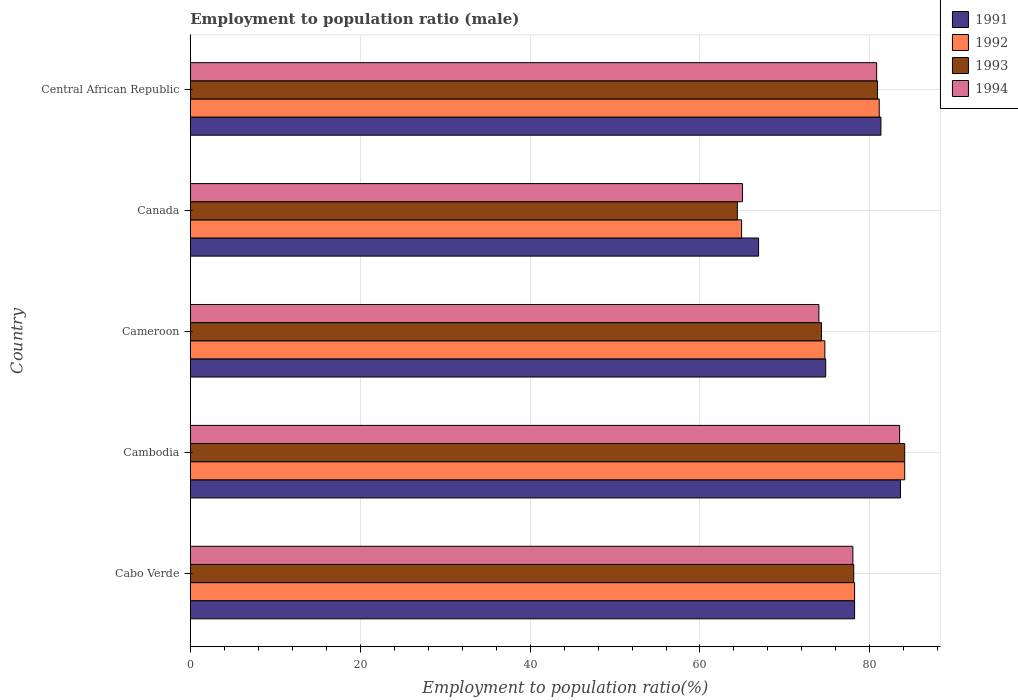How many groups of bars are there?
Offer a terse response. 5. Are the number of bars per tick equal to the number of legend labels?
Your answer should be compact. Yes. Are the number of bars on each tick of the Y-axis equal?
Your answer should be compact. Yes. How many bars are there on the 2nd tick from the top?
Ensure brevity in your answer.  4. What is the label of the 4th group of bars from the top?
Offer a very short reply. Cambodia. In how many cases, is the number of bars for a given country not equal to the number of legend labels?
Your response must be concise. 0. What is the employment to population ratio in 1994 in Cambodia?
Your answer should be very brief. 83.5. Across all countries, what is the maximum employment to population ratio in 1991?
Make the answer very short. 83.6. In which country was the employment to population ratio in 1991 maximum?
Provide a short and direct response. Cambodia. In which country was the employment to population ratio in 1991 minimum?
Offer a terse response. Canada. What is the total employment to population ratio in 1991 in the graph?
Ensure brevity in your answer.  384.8. What is the difference between the employment to population ratio in 1992 in Cameroon and that in Canada?
Your response must be concise. 9.8. What is the difference between the employment to population ratio in 1991 in Central African Republic and the employment to population ratio in 1993 in Canada?
Your answer should be compact. 16.9. What is the average employment to population ratio in 1992 per country?
Provide a succinct answer. 76.6. What is the difference between the employment to population ratio in 1993 and employment to population ratio in 1994 in Central African Republic?
Offer a very short reply. 0.1. In how many countries, is the employment to population ratio in 1991 greater than 64 %?
Offer a terse response. 5. What is the ratio of the employment to population ratio in 1992 in Cabo Verde to that in Canada?
Offer a terse response. 1.2. Is the employment to population ratio in 1991 in Cabo Verde less than that in Cameroon?
Provide a short and direct response. No. What is the difference between the highest and the second highest employment to population ratio in 1994?
Provide a succinct answer. 2.7. Is it the case that in every country, the sum of the employment to population ratio in 1991 and employment to population ratio in 1993 is greater than the sum of employment to population ratio in 1994 and employment to population ratio in 1992?
Provide a succinct answer. No. What does the 3rd bar from the top in Central African Republic represents?
Make the answer very short. 1992. What does the 2nd bar from the bottom in Central African Republic represents?
Your answer should be very brief. 1992. Are all the bars in the graph horizontal?
Give a very brief answer. Yes. How many countries are there in the graph?
Offer a terse response. 5. Are the values on the major ticks of X-axis written in scientific E-notation?
Provide a short and direct response. No. Does the graph contain grids?
Offer a terse response. Yes. How many legend labels are there?
Your answer should be very brief. 4. How are the legend labels stacked?
Keep it short and to the point. Vertical. What is the title of the graph?
Provide a short and direct response. Employment to population ratio (male). What is the label or title of the X-axis?
Keep it short and to the point. Employment to population ratio(%). What is the Employment to population ratio(%) of 1991 in Cabo Verde?
Your answer should be compact. 78.2. What is the Employment to population ratio(%) in 1992 in Cabo Verde?
Your response must be concise. 78.2. What is the Employment to population ratio(%) of 1993 in Cabo Verde?
Offer a very short reply. 78.1. What is the Employment to population ratio(%) in 1991 in Cambodia?
Provide a short and direct response. 83.6. What is the Employment to population ratio(%) in 1992 in Cambodia?
Make the answer very short. 84.1. What is the Employment to population ratio(%) in 1993 in Cambodia?
Your answer should be compact. 84.1. What is the Employment to population ratio(%) of 1994 in Cambodia?
Provide a succinct answer. 83.5. What is the Employment to population ratio(%) in 1991 in Cameroon?
Provide a succinct answer. 74.8. What is the Employment to population ratio(%) of 1992 in Cameroon?
Keep it short and to the point. 74.7. What is the Employment to population ratio(%) in 1993 in Cameroon?
Keep it short and to the point. 74.3. What is the Employment to population ratio(%) of 1994 in Cameroon?
Offer a terse response. 74. What is the Employment to population ratio(%) in 1991 in Canada?
Your answer should be compact. 66.9. What is the Employment to population ratio(%) of 1992 in Canada?
Offer a very short reply. 64.9. What is the Employment to population ratio(%) in 1993 in Canada?
Keep it short and to the point. 64.4. What is the Employment to population ratio(%) in 1991 in Central African Republic?
Ensure brevity in your answer.  81.3. What is the Employment to population ratio(%) in 1992 in Central African Republic?
Your answer should be very brief. 81.1. What is the Employment to population ratio(%) in 1993 in Central African Republic?
Make the answer very short. 80.9. What is the Employment to population ratio(%) of 1994 in Central African Republic?
Give a very brief answer. 80.8. Across all countries, what is the maximum Employment to population ratio(%) of 1991?
Offer a terse response. 83.6. Across all countries, what is the maximum Employment to population ratio(%) in 1992?
Provide a short and direct response. 84.1. Across all countries, what is the maximum Employment to population ratio(%) of 1993?
Make the answer very short. 84.1. Across all countries, what is the maximum Employment to population ratio(%) in 1994?
Provide a short and direct response. 83.5. Across all countries, what is the minimum Employment to population ratio(%) of 1991?
Your answer should be very brief. 66.9. Across all countries, what is the minimum Employment to population ratio(%) of 1992?
Ensure brevity in your answer.  64.9. Across all countries, what is the minimum Employment to population ratio(%) in 1993?
Ensure brevity in your answer.  64.4. What is the total Employment to population ratio(%) in 1991 in the graph?
Provide a short and direct response. 384.8. What is the total Employment to population ratio(%) in 1992 in the graph?
Provide a succinct answer. 383. What is the total Employment to population ratio(%) of 1993 in the graph?
Ensure brevity in your answer.  381.8. What is the total Employment to population ratio(%) in 1994 in the graph?
Offer a terse response. 381.3. What is the difference between the Employment to population ratio(%) of 1991 in Cabo Verde and that in Cambodia?
Give a very brief answer. -5.4. What is the difference between the Employment to population ratio(%) in 1994 in Cabo Verde and that in Cambodia?
Keep it short and to the point. -5.5. What is the difference between the Employment to population ratio(%) of 1992 in Cabo Verde and that in Cameroon?
Your answer should be compact. 3.5. What is the difference between the Employment to population ratio(%) of 1993 in Cabo Verde and that in Cameroon?
Your answer should be very brief. 3.8. What is the difference between the Employment to population ratio(%) of 1994 in Cabo Verde and that in Canada?
Ensure brevity in your answer.  13. What is the difference between the Employment to population ratio(%) in 1992 in Cabo Verde and that in Central African Republic?
Your answer should be very brief. -2.9. What is the difference between the Employment to population ratio(%) of 1993 in Cabo Verde and that in Central African Republic?
Provide a succinct answer. -2.8. What is the difference between the Employment to population ratio(%) in 1994 in Cabo Verde and that in Central African Republic?
Keep it short and to the point. -2.8. What is the difference between the Employment to population ratio(%) of 1992 in Cambodia and that in Cameroon?
Provide a short and direct response. 9.4. What is the difference between the Employment to population ratio(%) in 1993 in Cambodia and that in Cameroon?
Your answer should be very brief. 9.8. What is the difference between the Employment to population ratio(%) in 1991 in Cambodia and that in Canada?
Your response must be concise. 16.7. What is the difference between the Employment to population ratio(%) of 1992 in Cambodia and that in Canada?
Offer a terse response. 19.2. What is the difference between the Employment to population ratio(%) of 1993 in Cambodia and that in Canada?
Provide a succinct answer. 19.7. What is the difference between the Employment to population ratio(%) of 1994 in Cambodia and that in Canada?
Your answer should be very brief. 18.5. What is the difference between the Employment to population ratio(%) of 1991 in Cambodia and that in Central African Republic?
Make the answer very short. 2.3. What is the difference between the Employment to population ratio(%) in 1993 in Cameroon and that in Canada?
Offer a very short reply. 9.9. What is the difference between the Employment to population ratio(%) of 1994 in Cameroon and that in Canada?
Give a very brief answer. 9. What is the difference between the Employment to population ratio(%) in 1992 in Cameroon and that in Central African Republic?
Make the answer very short. -6.4. What is the difference between the Employment to population ratio(%) in 1993 in Cameroon and that in Central African Republic?
Your answer should be very brief. -6.6. What is the difference between the Employment to population ratio(%) of 1994 in Cameroon and that in Central African Republic?
Keep it short and to the point. -6.8. What is the difference between the Employment to population ratio(%) in 1991 in Canada and that in Central African Republic?
Give a very brief answer. -14.4. What is the difference between the Employment to population ratio(%) in 1992 in Canada and that in Central African Republic?
Your answer should be compact. -16.2. What is the difference between the Employment to population ratio(%) in 1993 in Canada and that in Central African Republic?
Keep it short and to the point. -16.5. What is the difference between the Employment to population ratio(%) in 1994 in Canada and that in Central African Republic?
Give a very brief answer. -15.8. What is the difference between the Employment to population ratio(%) of 1991 in Cabo Verde and the Employment to population ratio(%) of 1994 in Cambodia?
Your answer should be very brief. -5.3. What is the difference between the Employment to population ratio(%) in 1992 in Cabo Verde and the Employment to population ratio(%) in 1994 in Cambodia?
Your answer should be compact. -5.3. What is the difference between the Employment to population ratio(%) in 1993 in Cabo Verde and the Employment to population ratio(%) in 1994 in Cambodia?
Give a very brief answer. -5.4. What is the difference between the Employment to population ratio(%) in 1991 in Cabo Verde and the Employment to population ratio(%) in 1993 in Cameroon?
Keep it short and to the point. 3.9. What is the difference between the Employment to population ratio(%) in 1992 in Cabo Verde and the Employment to population ratio(%) in 1993 in Cameroon?
Offer a terse response. 3.9. What is the difference between the Employment to population ratio(%) of 1992 in Cabo Verde and the Employment to population ratio(%) of 1994 in Cameroon?
Your answer should be very brief. 4.2. What is the difference between the Employment to population ratio(%) in 1991 in Cabo Verde and the Employment to population ratio(%) in 1992 in Canada?
Your response must be concise. 13.3. What is the difference between the Employment to population ratio(%) of 1992 in Cabo Verde and the Employment to population ratio(%) of 1993 in Canada?
Provide a succinct answer. 13.8. What is the difference between the Employment to population ratio(%) in 1993 in Cabo Verde and the Employment to population ratio(%) in 1994 in Canada?
Offer a terse response. 13.1. What is the difference between the Employment to population ratio(%) of 1991 in Cabo Verde and the Employment to population ratio(%) of 1992 in Central African Republic?
Ensure brevity in your answer.  -2.9. What is the difference between the Employment to population ratio(%) in 1991 in Cabo Verde and the Employment to population ratio(%) in 1993 in Central African Republic?
Give a very brief answer. -2.7. What is the difference between the Employment to population ratio(%) in 1991 in Cabo Verde and the Employment to population ratio(%) in 1994 in Central African Republic?
Your answer should be very brief. -2.6. What is the difference between the Employment to population ratio(%) in 1992 in Cabo Verde and the Employment to population ratio(%) in 1993 in Central African Republic?
Your response must be concise. -2.7. What is the difference between the Employment to population ratio(%) in 1991 in Cambodia and the Employment to population ratio(%) in 1992 in Cameroon?
Offer a terse response. 8.9. What is the difference between the Employment to population ratio(%) of 1991 in Cambodia and the Employment to population ratio(%) of 1994 in Canada?
Provide a short and direct response. 18.6. What is the difference between the Employment to population ratio(%) in 1992 in Cambodia and the Employment to population ratio(%) in 1993 in Canada?
Your answer should be compact. 19.7. What is the difference between the Employment to population ratio(%) of 1993 in Cambodia and the Employment to population ratio(%) of 1994 in Canada?
Your answer should be compact. 19.1. What is the difference between the Employment to population ratio(%) of 1991 in Cambodia and the Employment to population ratio(%) of 1992 in Central African Republic?
Your response must be concise. 2.5. What is the difference between the Employment to population ratio(%) of 1991 in Cambodia and the Employment to population ratio(%) of 1993 in Central African Republic?
Your answer should be very brief. 2.7. What is the difference between the Employment to population ratio(%) in 1992 in Cambodia and the Employment to population ratio(%) in 1994 in Central African Republic?
Ensure brevity in your answer.  3.3. What is the difference between the Employment to population ratio(%) of 1991 in Cameroon and the Employment to population ratio(%) of 1993 in Canada?
Your answer should be very brief. 10.4. What is the difference between the Employment to population ratio(%) in 1992 in Cameroon and the Employment to population ratio(%) in 1994 in Canada?
Your answer should be compact. 9.7. What is the difference between the Employment to population ratio(%) in 1993 in Cameroon and the Employment to population ratio(%) in 1994 in Canada?
Provide a short and direct response. 9.3. What is the difference between the Employment to population ratio(%) of 1991 in Cameroon and the Employment to population ratio(%) of 1993 in Central African Republic?
Keep it short and to the point. -6.1. What is the difference between the Employment to population ratio(%) in 1991 in Cameroon and the Employment to population ratio(%) in 1994 in Central African Republic?
Your answer should be very brief. -6. What is the difference between the Employment to population ratio(%) in 1992 in Cameroon and the Employment to population ratio(%) in 1994 in Central African Republic?
Offer a terse response. -6.1. What is the difference between the Employment to population ratio(%) of 1991 in Canada and the Employment to population ratio(%) of 1993 in Central African Republic?
Your answer should be very brief. -14. What is the difference between the Employment to population ratio(%) in 1992 in Canada and the Employment to population ratio(%) in 1993 in Central African Republic?
Your response must be concise. -16. What is the difference between the Employment to population ratio(%) of 1992 in Canada and the Employment to population ratio(%) of 1994 in Central African Republic?
Provide a succinct answer. -15.9. What is the difference between the Employment to population ratio(%) in 1993 in Canada and the Employment to population ratio(%) in 1994 in Central African Republic?
Offer a terse response. -16.4. What is the average Employment to population ratio(%) of 1991 per country?
Provide a short and direct response. 76.96. What is the average Employment to population ratio(%) in 1992 per country?
Keep it short and to the point. 76.6. What is the average Employment to population ratio(%) of 1993 per country?
Ensure brevity in your answer.  76.36. What is the average Employment to population ratio(%) of 1994 per country?
Offer a terse response. 76.26. What is the difference between the Employment to population ratio(%) in 1991 and Employment to population ratio(%) in 1994 in Cabo Verde?
Make the answer very short. 0.2. What is the difference between the Employment to population ratio(%) in 1991 and Employment to population ratio(%) in 1992 in Cambodia?
Ensure brevity in your answer.  -0.5. What is the difference between the Employment to population ratio(%) of 1991 and Employment to population ratio(%) of 1993 in Cambodia?
Provide a succinct answer. -0.5. What is the difference between the Employment to population ratio(%) in 1991 and Employment to population ratio(%) in 1993 in Cameroon?
Provide a short and direct response. 0.5. What is the difference between the Employment to population ratio(%) of 1992 and Employment to population ratio(%) of 1994 in Cameroon?
Provide a succinct answer. 0.7. What is the difference between the Employment to population ratio(%) of 1991 and Employment to population ratio(%) of 1992 in Canada?
Provide a short and direct response. 2. What is the difference between the Employment to population ratio(%) of 1991 and Employment to population ratio(%) of 1993 in Canada?
Ensure brevity in your answer.  2.5. What is the difference between the Employment to population ratio(%) in 1991 and Employment to population ratio(%) in 1994 in Canada?
Provide a short and direct response. 1.9. What is the difference between the Employment to population ratio(%) in 1992 and Employment to population ratio(%) in 1993 in Canada?
Provide a succinct answer. 0.5. What is the difference between the Employment to population ratio(%) in 1991 and Employment to population ratio(%) in 1992 in Central African Republic?
Your response must be concise. 0.2. What is the difference between the Employment to population ratio(%) in 1992 and Employment to population ratio(%) in 1994 in Central African Republic?
Make the answer very short. 0.3. What is the difference between the Employment to population ratio(%) in 1993 and Employment to population ratio(%) in 1994 in Central African Republic?
Ensure brevity in your answer.  0.1. What is the ratio of the Employment to population ratio(%) in 1991 in Cabo Verde to that in Cambodia?
Offer a terse response. 0.94. What is the ratio of the Employment to population ratio(%) of 1992 in Cabo Verde to that in Cambodia?
Provide a succinct answer. 0.93. What is the ratio of the Employment to population ratio(%) in 1993 in Cabo Verde to that in Cambodia?
Your response must be concise. 0.93. What is the ratio of the Employment to population ratio(%) in 1994 in Cabo Verde to that in Cambodia?
Give a very brief answer. 0.93. What is the ratio of the Employment to population ratio(%) in 1991 in Cabo Verde to that in Cameroon?
Offer a terse response. 1.05. What is the ratio of the Employment to population ratio(%) in 1992 in Cabo Verde to that in Cameroon?
Provide a succinct answer. 1.05. What is the ratio of the Employment to population ratio(%) in 1993 in Cabo Verde to that in Cameroon?
Your answer should be very brief. 1.05. What is the ratio of the Employment to population ratio(%) in 1994 in Cabo Verde to that in Cameroon?
Ensure brevity in your answer.  1.05. What is the ratio of the Employment to population ratio(%) in 1991 in Cabo Verde to that in Canada?
Offer a very short reply. 1.17. What is the ratio of the Employment to population ratio(%) of 1992 in Cabo Verde to that in Canada?
Give a very brief answer. 1.2. What is the ratio of the Employment to population ratio(%) of 1993 in Cabo Verde to that in Canada?
Keep it short and to the point. 1.21. What is the ratio of the Employment to population ratio(%) in 1994 in Cabo Verde to that in Canada?
Ensure brevity in your answer.  1.2. What is the ratio of the Employment to population ratio(%) in 1991 in Cabo Verde to that in Central African Republic?
Your answer should be compact. 0.96. What is the ratio of the Employment to population ratio(%) of 1992 in Cabo Verde to that in Central African Republic?
Your response must be concise. 0.96. What is the ratio of the Employment to population ratio(%) in 1993 in Cabo Verde to that in Central African Republic?
Your response must be concise. 0.97. What is the ratio of the Employment to population ratio(%) in 1994 in Cabo Verde to that in Central African Republic?
Your answer should be compact. 0.97. What is the ratio of the Employment to population ratio(%) in 1991 in Cambodia to that in Cameroon?
Provide a succinct answer. 1.12. What is the ratio of the Employment to population ratio(%) of 1992 in Cambodia to that in Cameroon?
Your response must be concise. 1.13. What is the ratio of the Employment to population ratio(%) in 1993 in Cambodia to that in Cameroon?
Ensure brevity in your answer.  1.13. What is the ratio of the Employment to population ratio(%) in 1994 in Cambodia to that in Cameroon?
Your answer should be compact. 1.13. What is the ratio of the Employment to population ratio(%) in 1991 in Cambodia to that in Canada?
Ensure brevity in your answer.  1.25. What is the ratio of the Employment to population ratio(%) in 1992 in Cambodia to that in Canada?
Provide a short and direct response. 1.3. What is the ratio of the Employment to population ratio(%) of 1993 in Cambodia to that in Canada?
Provide a short and direct response. 1.31. What is the ratio of the Employment to population ratio(%) in 1994 in Cambodia to that in Canada?
Offer a very short reply. 1.28. What is the ratio of the Employment to population ratio(%) in 1991 in Cambodia to that in Central African Republic?
Offer a very short reply. 1.03. What is the ratio of the Employment to population ratio(%) in 1992 in Cambodia to that in Central African Republic?
Offer a very short reply. 1.04. What is the ratio of the Employment to population ratio(%) in 1993 in Cambodia to that in Central African Republic?
Your answer should be compact. 1.04. What is the ratio of the Employment to population ratio(%) of 1994 in Cambodia to that in Central African Republic?
Your answer should be compact. 1.03. What is the ratio of the Employment to population ratio(%) in 1991 in Cameroon to that in Canada?
Offer a terse response. 1.12. What is the ratio of the Employment to population ratio(%) of 1992 in Cameroon to that in Canada?
Provide a succinct answer. 1.15. What is the ratio of the Employment to population ratio(%) in 1993 in Cameroon to that in Canada?
Make the answer very short. 1.15. What is the ratio of the Employment to population ratio(%) in 1994 in Cameroon to that in Canada?
Provide a short and direct response. 1.14. What is the ratio of the Employment to population ratio(%) in 1992 in Cameroon to that in Central African Republic?
Your response must be concise. 0.92. What is the ratio of the Employment to population ratio(%) in 1993 in Cameroon to that in Central African Republic?
Provide a succinct answer. 0.92. What is the ratio of the Employment to population ratio(%) in 1994 in Cameroon to that in Central African Republic?
Offer a terse response. 0.92. What is the ratio of the Employment to population ratio(%) of 1991 in Canada to that in Central African Republic?
Provide a succinct answer. 0.82. What is the ratio of the Employment to population ratio(%) in 1992 in Canada to that in Central African Republic?
Your response must be concise. 0.8. What is the ratio of the Employment to population ratio(%) in 1993 in Canada to that in Central African Republic?
Provide a short and direct response. 0.8. What is the ratio of the Employment to population ratio(%) of 1994 in Canada to that in Central African Republic?
Your answer should be compact. 0.8. What is the difference between the highest and the second highest Employment to population ratio(%) in 1991?
Offer a terse response. 2.3. What is the difference between the highest and the second highest Employment to population ratio(%) in 1993?
Keep it short and to the point. 3.2. What is the difference between the highest and the second highest Employment to population ratio(%) in 1994?
Your answer should be very brief. 2.7. What is the difference between the highest and the lowest Employment to population ratio(%) in 1992?
Give a very brief answer. 19.2. 